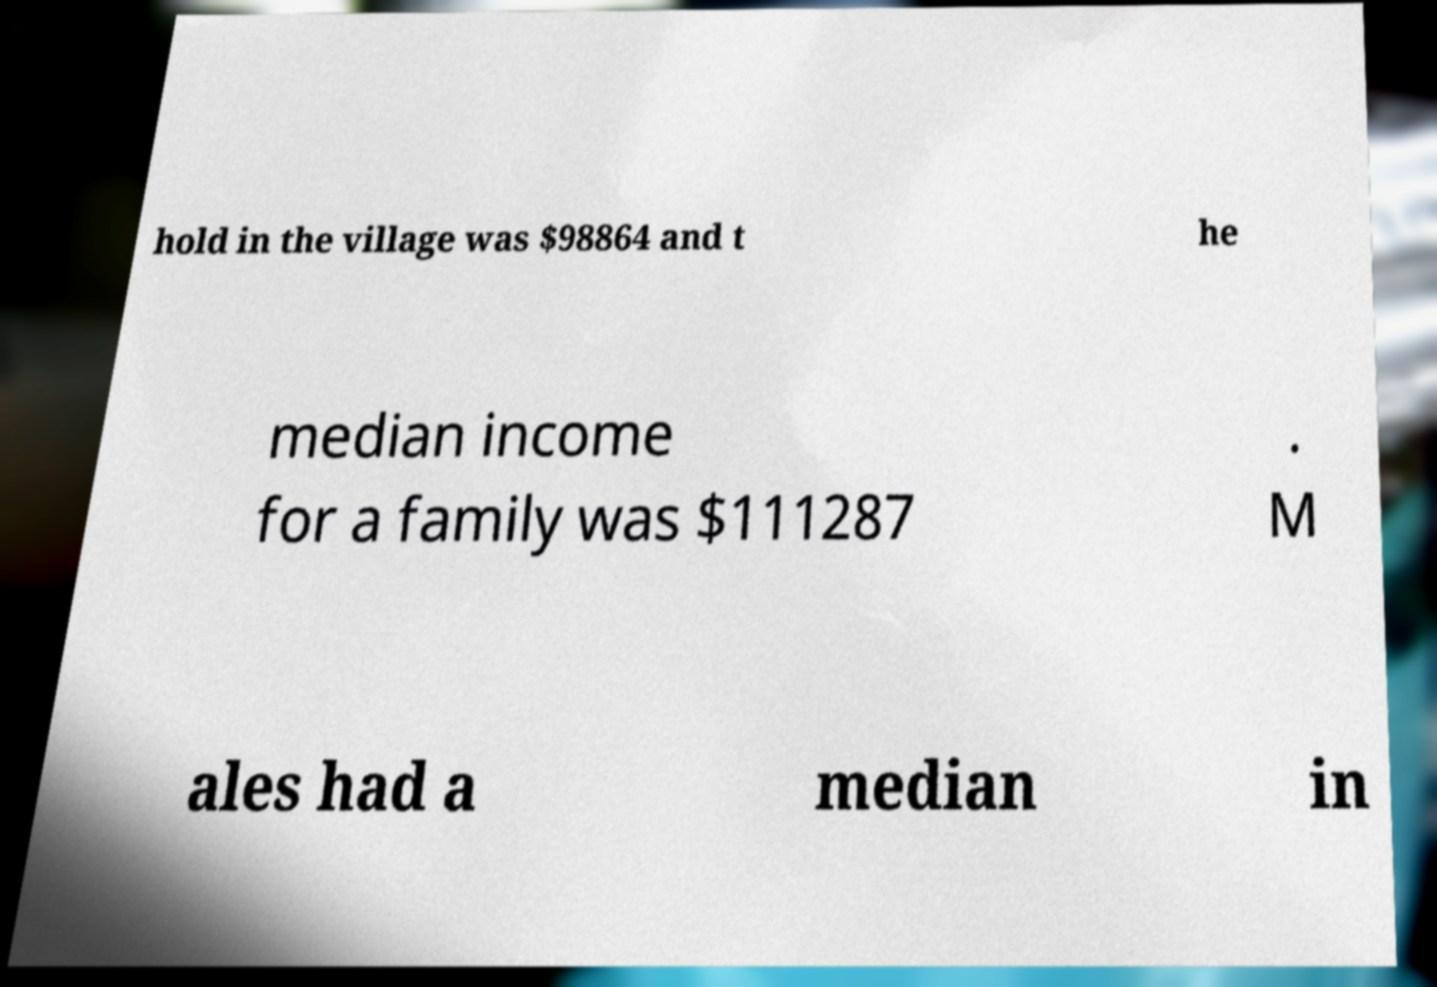I need the written content from this picture converted into text. Can you do that? hold in the village was $98864 and t he median income for a family was $111287 . M ales had a median in 